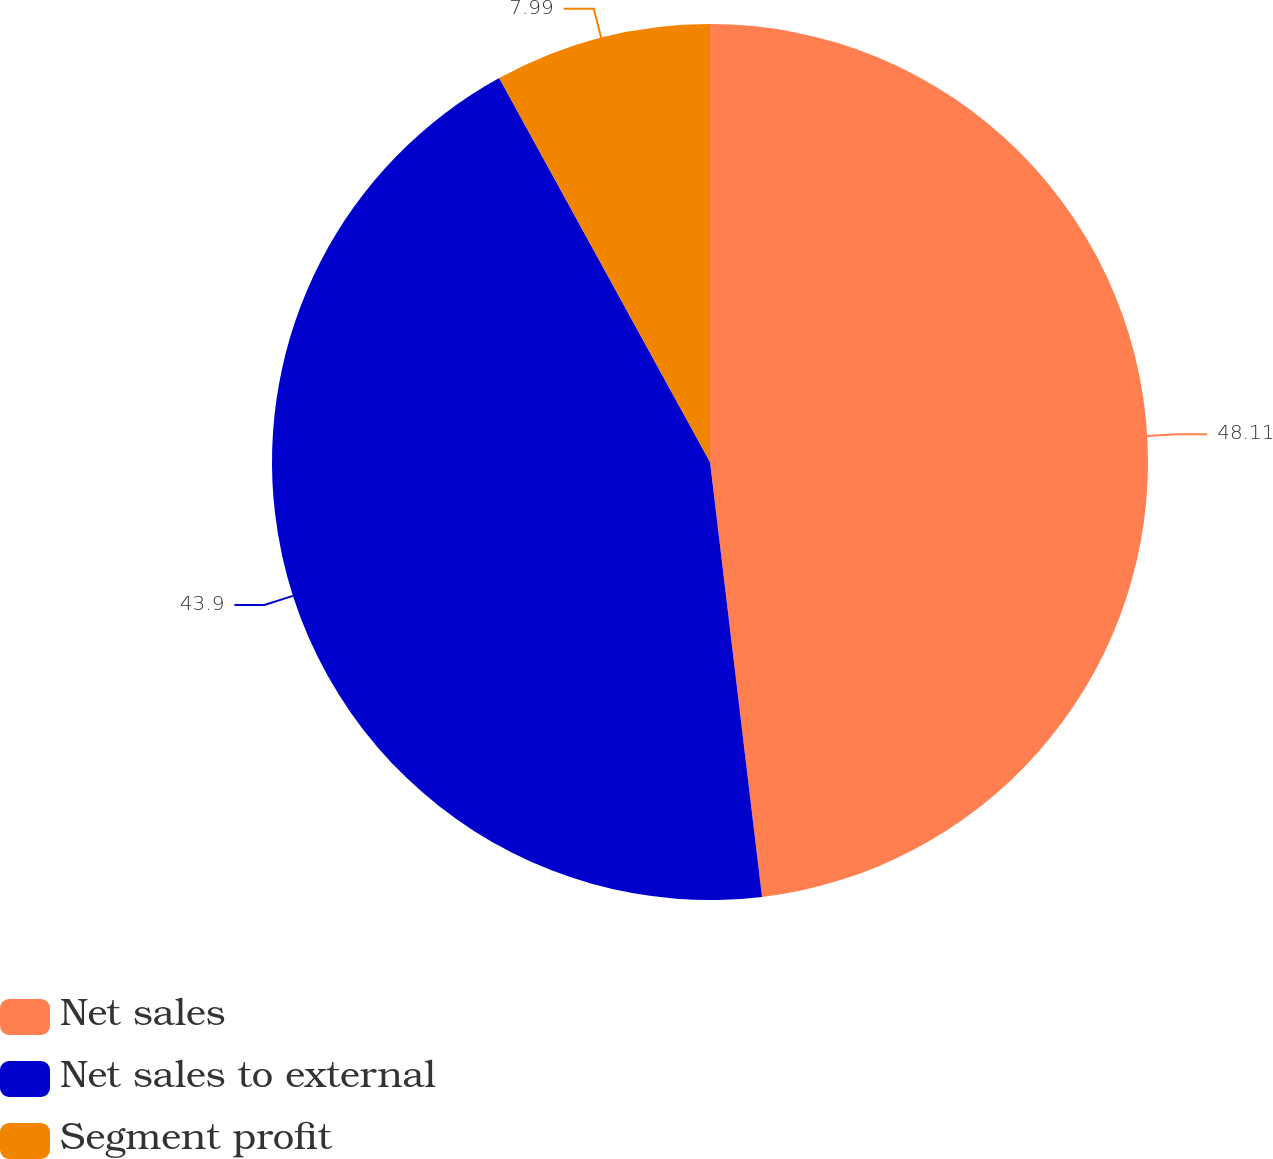Convert chart. <chart><loc_0><loc_0><loc_500><loc_500><pie_chart><fcel>Net sales<fcel>Net sales to external<fcel>Segment profit<nl><fcel>48.1%<fcel>43.9%<fcel>7.99%<nl></chart> 